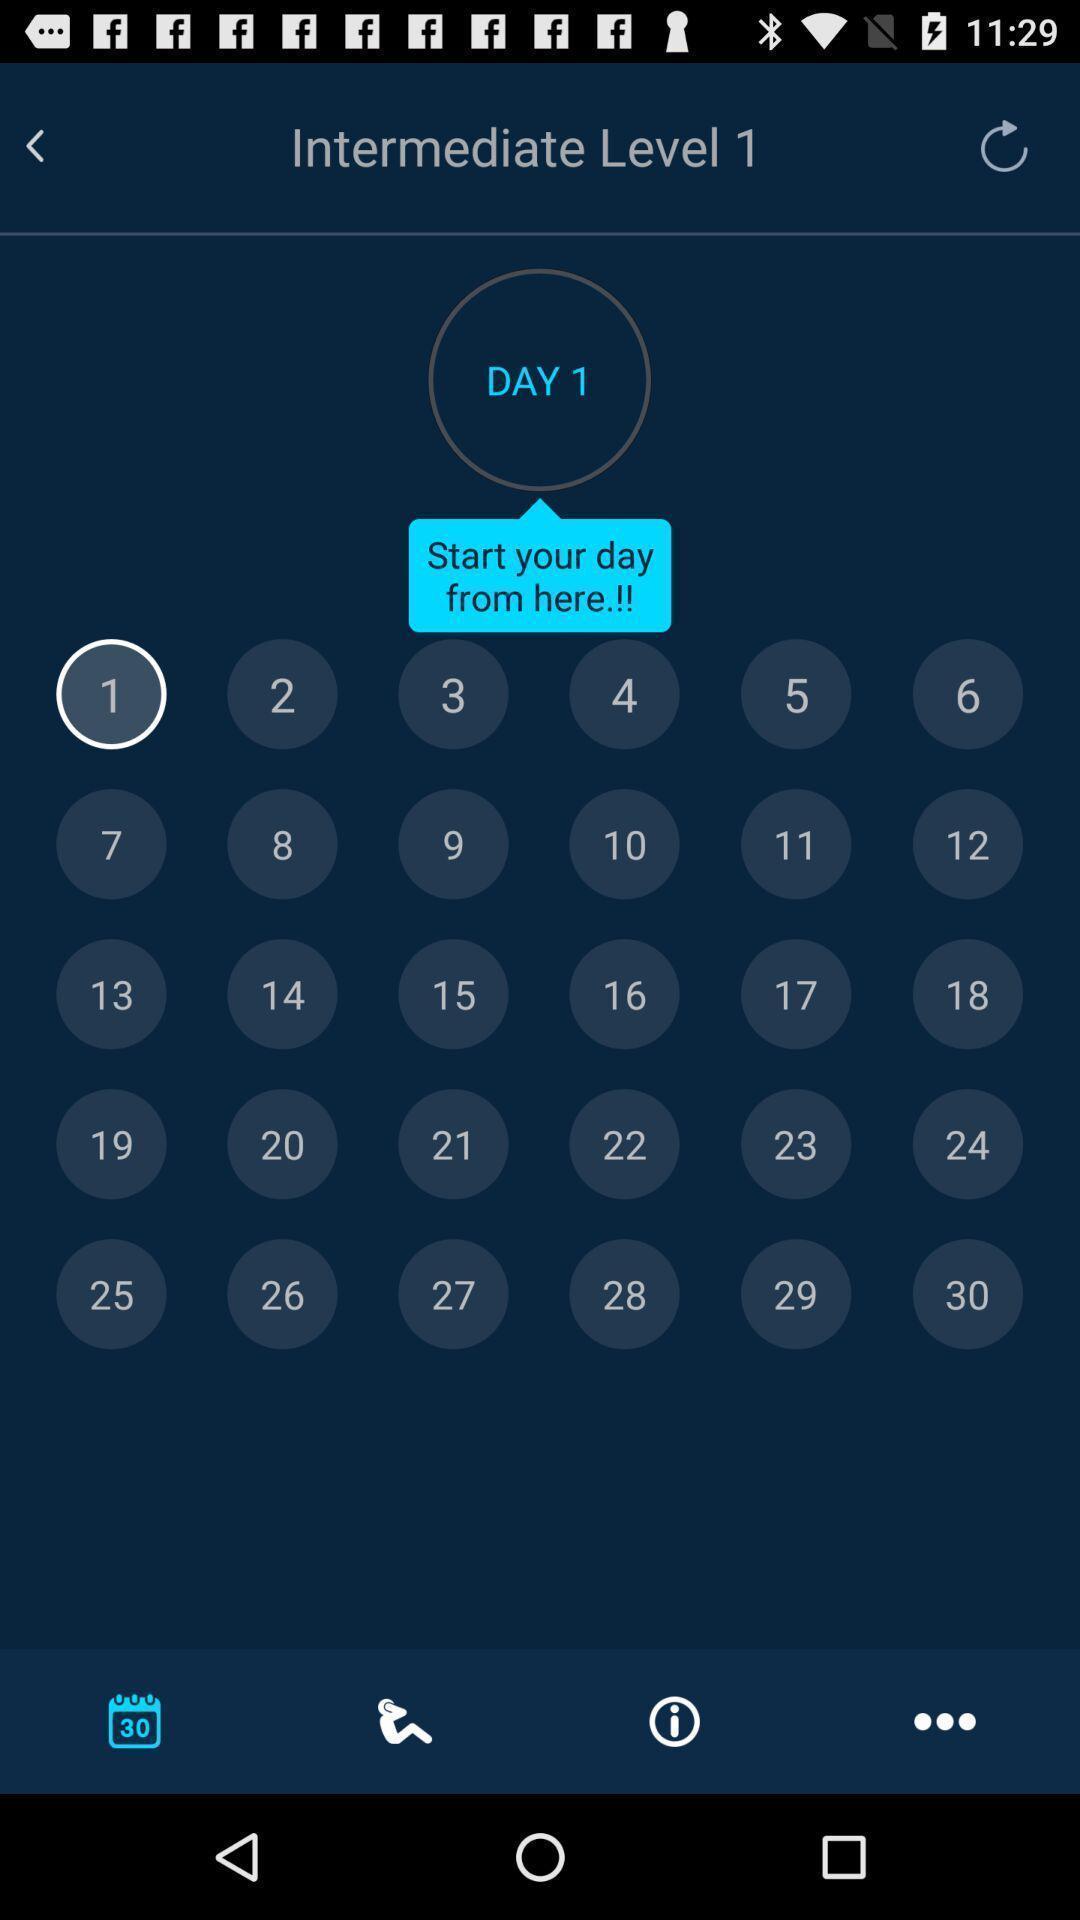Give me a narrative description of this picture. Page showing calendar. 